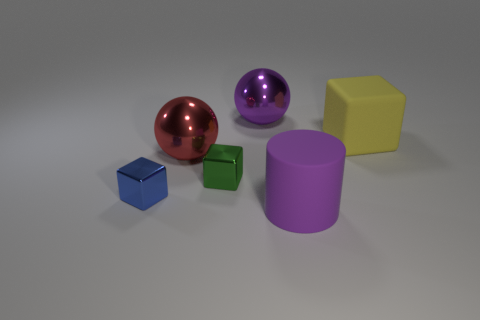How many balls are purple matte objects or small blue metallic things?
Your answer should be very brief. 0. There is a matte block that is the same size as the matte cylinder; what is its color?
Ensure brevity in your answer.  Yellow. There is a large metal object behind the block that is to the right of the rubber cylinder; are there any big purple things that are to the left of it?
Give a very brief answer. No. What size is the matte block?
Provide a succinct answer. Large. What number of objects are either metal blocks or big matte cylinders?
Your response must be concise. 3. What color is the other big ball that is the same material as the big purple sphere?
Provide a short and direct response. Red. There is a purple thing that is in front of the red shiny ball; is it the same shape as the tiny blue metallic thing?
Offer a very short reply. No. What number of things are rubber things to the right of the red ball or big purple things right of the large purple ball?
Your answer should be compact. 2. The large rubber object that is the same shape as the small green metallic thing is what color?
Keep it short and to the point. Yellow. Is there anything else that has the same shape as the big purple matte thing?
Your answer should be compact. No. 